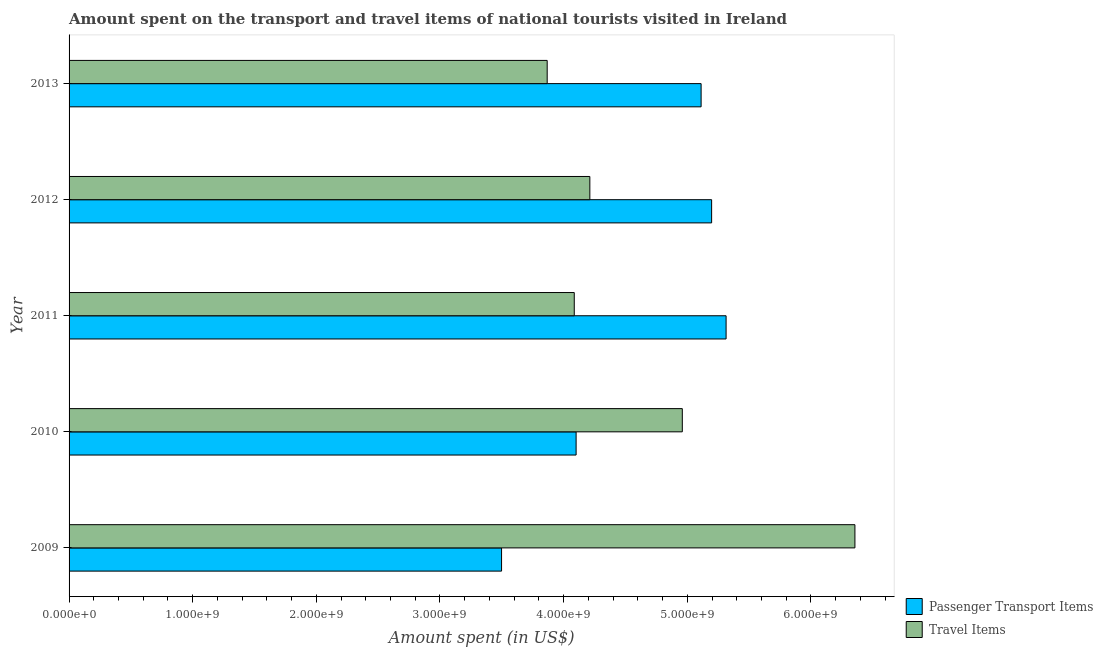How many different coloured bars are there?
Your response must be concise. 2. How many groups of bars are there?
Offer a terse response. 5. How many bars are there on the 5th tick from the top?
Ensure brevity in your answer.  2. How many bars are there on the 5th tick from the bottom?
Offer a terse response. 2. What is the label of the 4th group of bars from the top?
Make the answer very short. 2010. What is the amount spent in travel items in 2013?
Provide a succinct answer. 3.87e+09. Across all years, what is the maximum amount spent in travel items?
Offer a very short reply. 6.36e+09. Across all years, what is the minimum amount spent on passenger transport items?
Ensure brevity in your answer.  3.50e+09. In which year was the amount spent in travel items minimum?
Offer a terse response. 2013. What is the total amount spent on passenger transport items in the graph?
Give a very brief answer. 2.32e+1. What is the difference between the amount spent in travel items in 2010 and that in 2012?
Provide a short and direct response. 7.48e+08. What is the difference between the amount spent on passenger transport items in 2011 and the amount spent in travel items in 2010?
Ensure brevity in your answer.  3.54e+08. What is the average amount spent on passenger transport items per year?
Your answer should be very brief. 4.64e+09. In the year 2012, what is the difference between the amount spent on passenger transport items and amount spent in travel items?
Give a very brief answer. 9.85e+08. What is the ratio of the amount spent in travel items in 2009 to that in 2010?
Keep it short and to the point. 1.28. Is the amount spent on passenger transport items in 2009 less than that in 2010?
Your response must be concise. Yes. Is the difference between the amount spent on passenger transport items in 2011 and 2012 greater than the difference between the amount spent in travel items in 2011 and 2012?
Keep it short and to the point. Yes. What is the difference between the highest and the second highest amount spent in travel items?
Offer a terse response. 1.40e+09. What is the difference between the highest and the lowest amount spent on passenger transport items?
Offer a very short reply. 1.82e+09. In how many years, is the amount spent in travel items greater than the average amount spent in travel items taken over all years?
Your answer should be compact. 2. What does the 2nd bar from the top in 2012 represents?
Keep it short and to the point. Passenger Transport Items. What does the 2nd bar from the bottom in 2011 represents?
Your response must be concise. Travel Items. How many bars are there?
Your answer should be compact. 10. How many years are there in the graph?
Your answer should be very brief. 5. Does the graph contain any zero values?
Offer a very short reply. No. Does the graph contain grids?
Your response must be concise. No. Where does the legend appear in the graph?
Give a very brief answer. Bottom right. What is the title of the graph?
Offer a terse response. Amount spent on the transport and travel items of national tourists visited in Ireland. What is the label or title of the X-axis?
Your answer should be compact. Amount spent (in US$). What is the label or title of the Y-axis?
Provide a succinct answer. Year. What is the Amount spent (in US$) in Passenger Transport Items in 2009?
Give a very brief answer. 3.50e+09. What is the Amount spent (in US$) in Travel Items in 2009?
Your answer should be very brief. 6.36e+09. What is the Amount spent (in US$) in Passenger Transport Items in 2010?
Your answer should be compact. 4.10e+09. What is the Amount spent (in US$) of Travel Items in 2010?
Offer a terse response. 4.96e+09. What is the Amount spent (in US$) in Passenger Transport Items in 2011?
Offer a very short reply. 5.31e+09. What is the Amount spent (in US$) in Travel Items in 2011?
Make the answer very short. 4.09e+09. What is the Amount spent (in US$) in Passenger Transport Items in 2012?
Keep it short and to the point. 5.20e+09. What is the Amount spent (in US$) of Travel Items in 2012?
Keep it short and to the point. 4.21e+09. What is the Amount spent (in US$) in Passenger Transport Items in 2013?
Offer a very short reply. 5.11e+09. What is the Amount spent (in US$) of Travel Items in 2013?
Keep it short and to the point. 3.87e+09. Across all years, what is the maximum Amount spent (in US$) of Passenger Transport Items?
Your response must be concise. 5.31e+09. Across all years, what is the maximum Amount spent (in US$) in Travel Items?
Provide a short and direct response. 6.36e+09. Across all years, what is the minimum Amount spent (in US$) in Passenger Transport Items?
Offer a very short reply. 3.50e+09. Across all years, what is the minimum Amount spent (in US$) in Travel Items?
Keep it short and to the point. 3.87e+09. What is the total Amount spent (in US$) in Passenger Transport Items in the graph?
Ensure brevity in your answer.  2.32e+1. What is the total Amount spent (in US$) of Travel Items in the graph?
Your answer should be very brief. 2.35e+1. What is the difference between the Amount spent (in US$) of Passenger Transport Items in 2009 and that in 2010?
Ensure brevity in your answer.  -6.03e+08. What is the difference between the Amount spent (in US$) of Travel Items in 2009 and that in 2010?
Give a very brief answer. 1.40e+09. What is the difference between the Amount spent (in US$) of Passenger Transport Items in 2009 and that in 2011?
Keep it short and to the point. -1.82e+09. What is the difference between the Amount spent (in US$) in Travel Items in 2009 and that in 2011?
Your response must be concise. 2.27e+09. What is the difference between the Amount spent (in US$) in Passenger Transport Items in 2009 and that in 2012?
Offer a very short reply. -1.70e+09. What is the difference between the Amount spent (in US$) in Travel Items in 2009 and that in 2012?
Your answer should be very brief. 2.14e+09. What is the difference between the Amount spent (in US$) in Passenger Transport Items in 2009 and that in 2013?
Offer a very short reply. -1.61e+09. What is the difference between the Amount spent (in US$) of Travel Items in 2009 and that in 2013?
Keep it short and to the point. 2.49e+09. What is the difference between the Amount spent (in US$) of Passenger Transport Items in 2010 and that in 2011?
Ensure brevity in your answer.  -1.21e+09. What is the difference between the Amount spent (in US$) of Travel Items in 2010 and that in 2011?
Offer a terse response. 8.74e+08. What is the difference between the Amount spent (in US$) of Passenger Transport Items in 2010 and that in 2012?
Offer a very short reply. -1.10e+09. What is the difference between the Amount spent (in US$) in Travel Items in 2010 and that in 2012?
Provide a succinct answer. 7.48e+08. What is the difference between the Amount spent (in US$) in Passenger Transport Items in 2010 and that in 2013?
Provide a short and direct response. -1.01e+09. What is the difference between the Amount spent (in US$) in Travel Items in 2010 and that in 2013?
Keep it short and to the point. 1.09e+09. What is the difference between the Amount spent (in US$) in Passenger Transport Items in 2011 and that in 2012?
Your response must be concise. 1.17e+08. What is the difference between the Amount spent (in US$) in Travel Items in 2011 and that in 2012?
Keep it short and to the point. -1.26e+08. What is the difference between the Amount spent (in US$) in Passenger Transport Items in 2011 and that in 2013?
Keep it short and to the point. 2.02e+08. What is the difference between the Amount spent (in US$) in Travel Items in 2011 and that in 2013?
Your answer should be compact. 2.19e+08. What is the difference between the Amount spent (in US$) in Passenger Transport Items in 2012 and that in 2013?
Offer a very short reply. 8.50e+07. What is the difference between the Amount spent (in US$) in Travel Items in 2012 and that in 2013?
Your answer should be compact. 3.45e+08. What is the difference between the Amount spent (in US$) in Passenger Transport Items in 2009 and the Amount spent (in US$) in Travel Items in 2010?
Offer a terse response. -1.46e+09. What is the difference between the Amount spent (in US$) of Passenger Transport Items in 2009 and the Amount spent (in US$) of Travel Items in 2011?
Provide a succinct answer. -5.88e+08. What is the difference between the Amount spent (in US$) of Passenger Transport Items in 2009 and the Amount spent (in US$) of Travel Items in 2012?
Your answer should be very brief. -7.14e+08. What is the difference between the Amount spent (in US$) of Passenger Transport Items in 2009 and the Amount spent (in US$) of Travel Items in 2013?
Ensure brevity in your answer.  -3.69e+08. What is the difference between the Amount spent (in US$) of Passenger Transport Items in 2010 and the Amount spent (in US$) of Travel Items in 2011?
Your response must be concise. 1.50e+07. What is the difference between the Amount spent (in US$) of Passenger Transport Items in 2010 and the Amount spent (in US$) of Travel Items in 2012?
Offer a terse response. -1.11e+08. What is the difference between the Amount spent (in US$) of Passenger Transport Items in 2010 and the Amount spent (in US$) of Travel Items in 2013?
Make the answer very short. 2.34e+08. What is the difference between the Amount spent (in US$) of Passenger Transport Items in 2011 and the Amount spent (in US$) of Travel Items in 2012?
Keep it short and to the point. 1.10e+09. What is the difference between the Amount spent (in US$) of Passenger Transport Items in 2011 and the Amount spent (in US$) of Travel Items in 2013?
Ensure brevity in your answer.  1.45e+09. What is the difference between the Amount spent (in US$) in Passenger Transport Items in 2012 and the Amount spent (in US$) in Travel Items in 2013?
Give a very brief answer. 1.33e+09. What is the average Amount spent (in US$) in Passenger Transport Items per year?
Offer a very short reply. 4.64e+09. What is the average Amount spent (in US$) of Travel Items per year?
Your answer should be compact. 4.70e+09. In the year 2009, what is the difference between the Amount spent (in US$) of Passenger Transport Items and Amount spent (in US$) of Travel Items?
Keep it short and to the point. -2.86e+09. In the year 2010, what is the difference between the Amount spent (in US$) in Passenger Transport Items and Amount spent (in US$) in Travel Items?
Offer a terse response. -8.59e+08. In the year 2011, what is the difference between the Amount spent (in US$) of Passenger Transport Items and Amount spent (in US$) of Travel Items?
Keep it short and to the point. 1.23e+09. In the year 2012, what is the difference between the Amount spent (in US$) in Passenger Transport Items and Amount spent (in US$) in Travel Items?
Offer a very short reply. 9.85e+08. In the year 2013, what is the difference between the Amount spent (in US$) of Passenger Transport Items and Amount spent (in US$) of Travel Items?
Offer a terse response. 1.24e+09. What is the ratio of the Amount spent (in US$) of Passenger Transport Items in 2009 to that in 2010?
Your answer should be compact. 0.85. What is the ratio of the Amount spent (in US$) in Travel Items in 2009 to that in 2010?
Provide a short and direct response. 1.28. What is the ratio of the Amount spent (in US$) of Passenger Transport Items in 2009 to that in 2011?
Give a very brief answer. 0.66. What is the ratio of the Amount spent (in US$) of Travel Items in 2009 to that in 2011?
Keep it short and to the point. 1.56. What is the ratio of the Amount spent (in US$) in Passenger Transport Items in 2009 to that in 2012?
Your answer should be very brief. 0.67. What is the ratio of the Amount spent (in US$) in Travel Items in 2009 to that in 2012?
Provide a succinct answer. 1.51. What is the ratio of the Amount spent (in US$) of Passenger Transport Items in 2009 to that in 2013?
Your answer should be very brief. 0.68. What is the ratio of the Amount spent (in US$) of Travel Items in 2009 to that in 2013?
Make the answer very short. 1.64. What is the ratio of the Amount spent (in US$) of Passenger Transport Items in 2010 to that in 2011?
Make the answer very short. 0.77. What is the ratio of the Amount spent (in US$) of Travel Items in 2010 to that in 2011?
Give a very brief answer. 1.21. What is the ratio of the Amount spent (in US$) in Passenger Transport Items in 2010 to that in 2012?
Provide a short and direct response. 0.79. What is the ratio of the Amount spent (in US$) of Travel Items in 2010 to that in 2012?
Make the answer very short. 1.18. What is the ratio of the Amount spent (in US$) in Passenger Transport Items in 2010 to that in 2013?
Ensure brevity in your answer.  0.8. What is the ratio of the Amount spent (in US$) in Travel Items in 2010 to that in 2013?
Give a very brief answer. 1.28. What is the ratio of the Amount spent (in US$) of Passenger Transport Items in 2011 to that in 2012?
Make the answer very short. 1.02. What is the ratio of the Amount spent (in US$) of Travel Items in 2011 to that in 2012?
Provide a short and direct response. 0.97. What is the ratio of the Amount spent (in US$) of Passenger Transport Items in 2011 to that in 2013?
Offer a very short reply. 1.04. What is the ratio of the Amount spent (in US$) of Travel Items in 2011 to that in 2013?
Offer a very short reply. 1.06. What is the ratio of the Amount spent (in US$) in Passenger Transport Items in 2012 to that in 2013?
Your answer should be compact. 1.02. What is the ratio of the Amount spent (in US$) of Travel Items in 2012 to that in 2013?
Keep it short and to the point. 1.09. What is the difference between the highest and the second highest Amount spent (in US$) of Passenger Transport Items?
Your answer should be compact. 1.17e+08. What is the difference between the highest and the second highest Amount spent (in US$) in Travel Items?
Your answer should be very brief. 1.40e+09. What is the difference between the highest and the lowest Amount spent (in US$) of Passenger Transport Items?
Ensure brevity in your answer.  1.82e+09. What is the difference between the highest and the lowest Amount spent (in US$) in Travel Items?
Provide a short and direct response. 2.49e+09. 